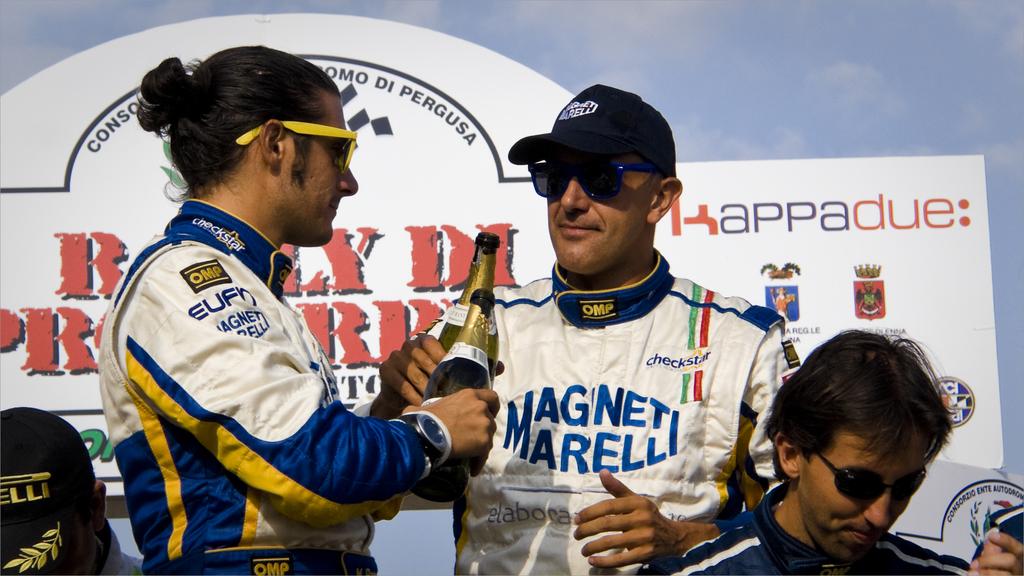What team are these people on?
Make the answer very short. Magnet marelli. What are the three letters in yellow on the black tag on his shoulder?
Provide a succinct answer. Omp. 